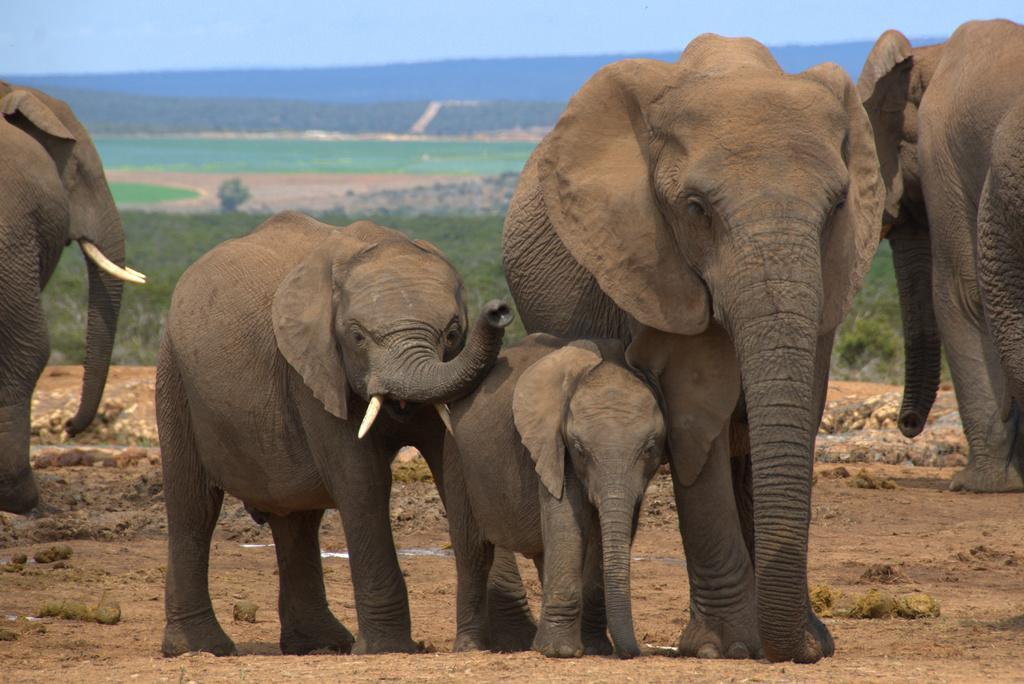Please provide a concise description of this image. This is an outside view. Here I can see few elephants on the ground. In the background, I can see the field and a hill. At the top there is a sky. 